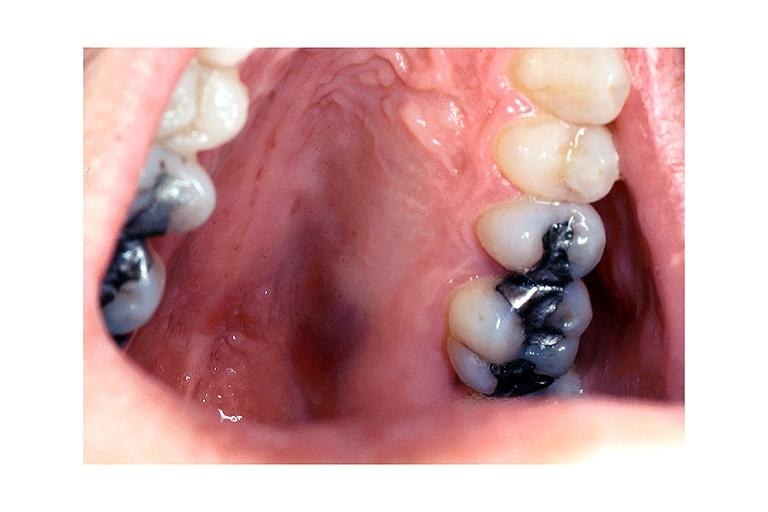where is this?
Answer the question using a single word or phrase. Oral 